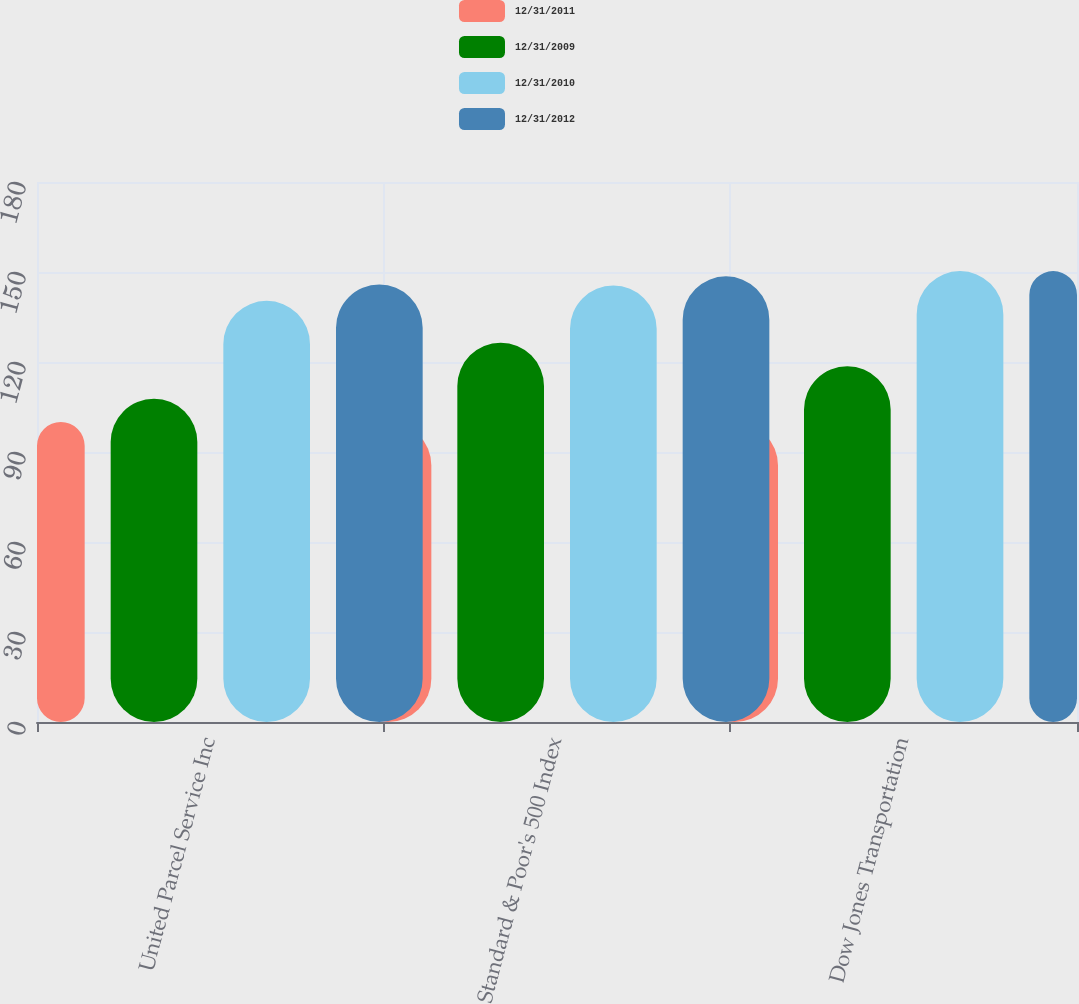<chart> <loc_0><loc_0><loc_500><loc_500><stacked_bar_chart><ecel><fcel>United Parcel Service Inc<fcel>Standard & Poor's 500 Index<fcel>Dow Jones Transportation<nl><fcel>12/31/2011<fcel>100<fcel>100<fcel>100<nl><fcel>12/31/2009<fcel>107.75<fcel>126.45<fcel>118.59<nl><fcel>12/31/2010<fcel>140.39<fcel>145.49<fcel>150.3<nl><fcel>12/31/2012<fcel>145.84<fcel>148.55<fcel>150.31<nl></chart> 